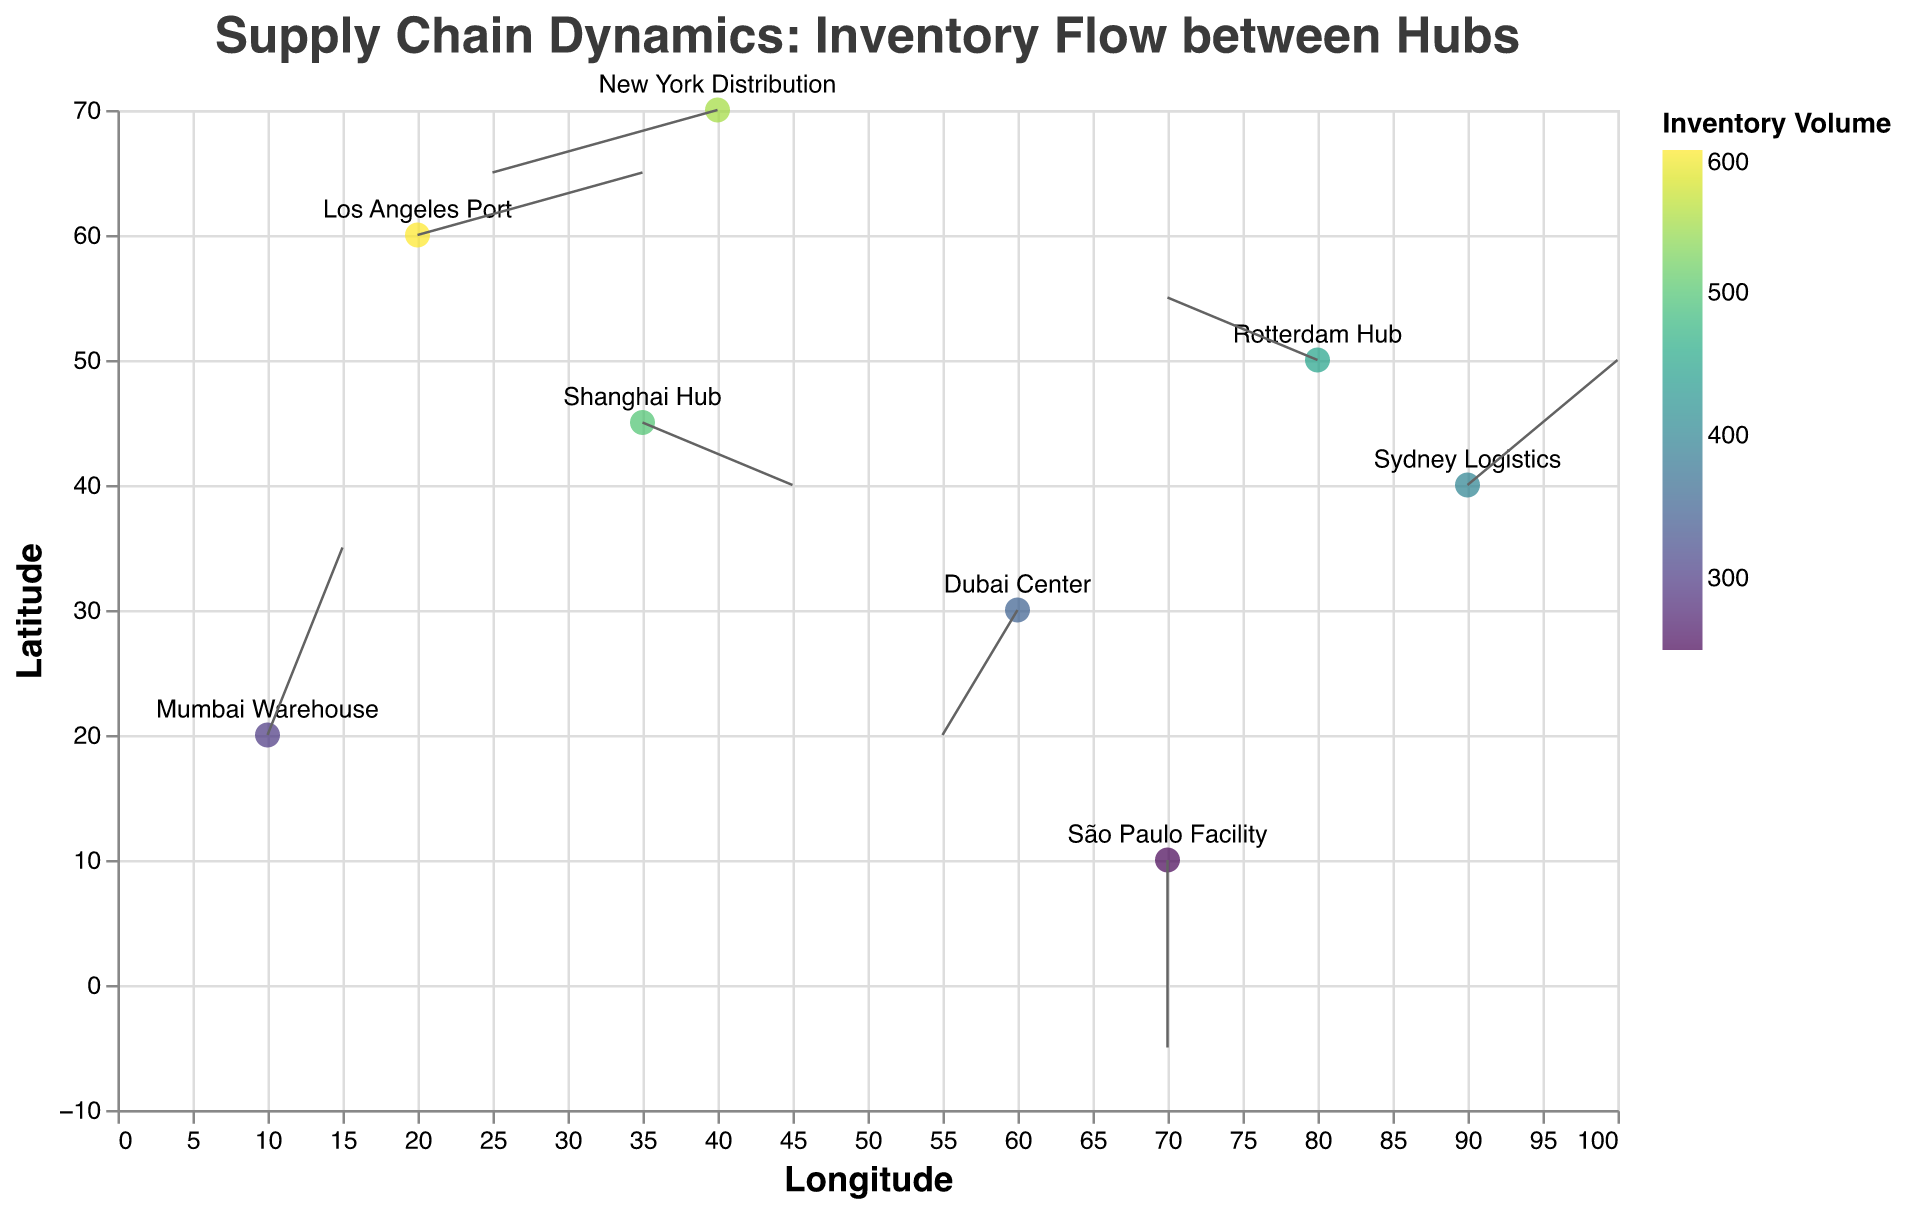Which hub has the highest inventory volume? From the data on the color scale and the tooltip information, the Los Angeles Port has the highest inventory volume of 600 units.
Answer: Los Angeles Port What is the direction of inventory flow at the São Paulo Facility? The direction of inventory flow is given by the vector components (u, v). For São Paulo Facility, the values are (0, -3), indicating the flow is straight downwards.
Answer: Downwards How many data points are represented in the plot? Counting the number of unique labels or data points provided in the data, there are eight locations represented.
Answer: Eight Which two locations have a similar direction of inventory flow? Comparing the vector components (u, v), both Shanghai Hub and Sydney Logistics display a (positive u, positive v) direction, but actually, Shanghai Hub (2, -1) differs from Sydney Logistics (2, 2). Instead, comparing u and v we can see that New York Distribution (-3, -1) and Dubai Center (-1, -2) both show negative u and negative v although not perfectly aligned.
Answer: No perfect matches; New York Distribution and Dubai Center are somewhat similar What is the magnitude of inventory at Mumbai Warehouse and how does it compare to Shanghai Hub? From the tooltips or color indications, Mumbai Warehouse has 300 units, whereas Shanghai Hub has 500 units, rendering Shanghai Hub's inventory 200 units higher.
Answer: Shanghai Hub has 200 more units Which location has the steepest inventory flow vector? The steepness of the flow vector can be determined by the largest (u^2 + v^2). Calculating for each, Los Angeles Port's vector (3, 1) results in sqrt(9+1)=sqrt(10), and comparing with others, Los Angeles Port indeed records the highest at magnitude sqrt(10) ≈ 3.16.
Answer: Los Angeles Port What are the x and y coordinates of the New York Distribution center? Referring to the label positioning on the plot, New York Distribution is found at coordinates (40, 70).
Answer: (40, 70) What is the average magnitude of inventory volume across all locations? Summing all magnitudes (500, 350, 600, 450, 300, 250, 550, 400) totals to 3400. Divided by the number of locations (8), the average is 3400/8 = 425.
Answer: 425 Which location has the shortest inventory flow vector? By calculating sqrt(u^2 + v^2) for each vector, the smallest result is seen at São Paulo Facility with vector (0, -3) equating to sqrt(0^2 + (-3)^2) = 3.
Answer: São Paulo Facility What is the sum of all positive u components in the dataset? Adding the positive u values: Shanghai Hub (2), Los Angeles Port (3), Mumbai Warehouse (1) and Sydney Logistics (2), we sum them as 2 + 3 + 1 + 2 = 8.
Answer: 8 